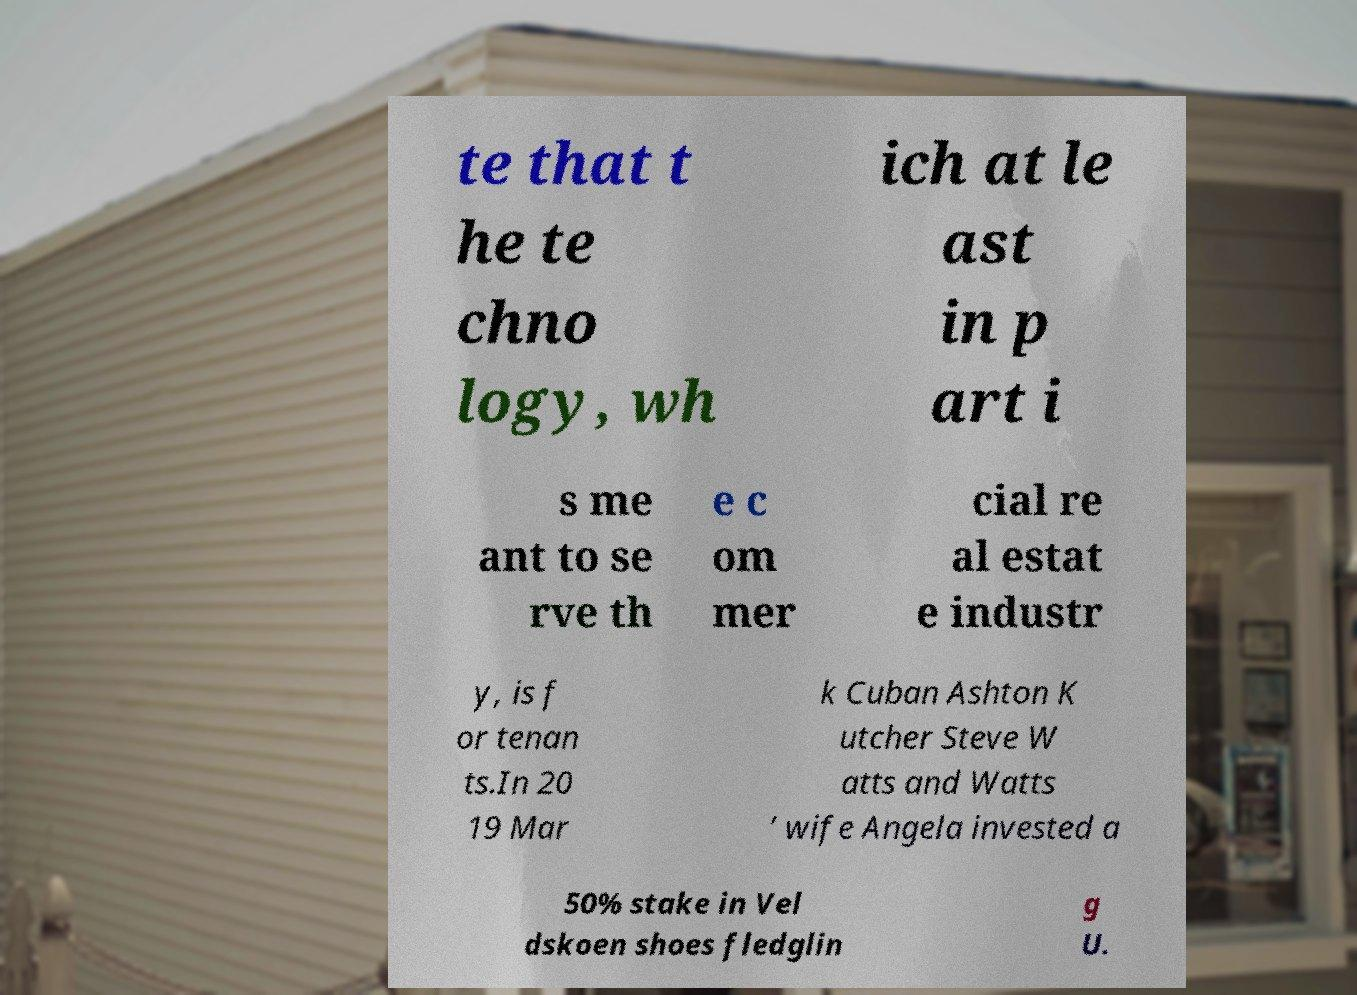I need the written content from this picture converted into text. Can you do that? te that t he te chno logy, wh ich at le ast in p art i s me ant to se rve th e c om mer cial re al estat e industr y, is f or tenan ts.In 20 19 Mar k Cuban Ashton K utcher Steve W atts and Watts ’ wife Angela invested a 50% stake in Vel dskoen shoes fledglin g U. 